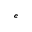Convert formula to latex. <formula><loc_0><loc_0><loc_500><loc_500>^ { e }</formula> 